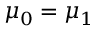Convert formula to latex. <formula><loc_0><loc_0><loc_500><loc_500>\mu _ { 0 } = \mu _ { 1 }</formula> 